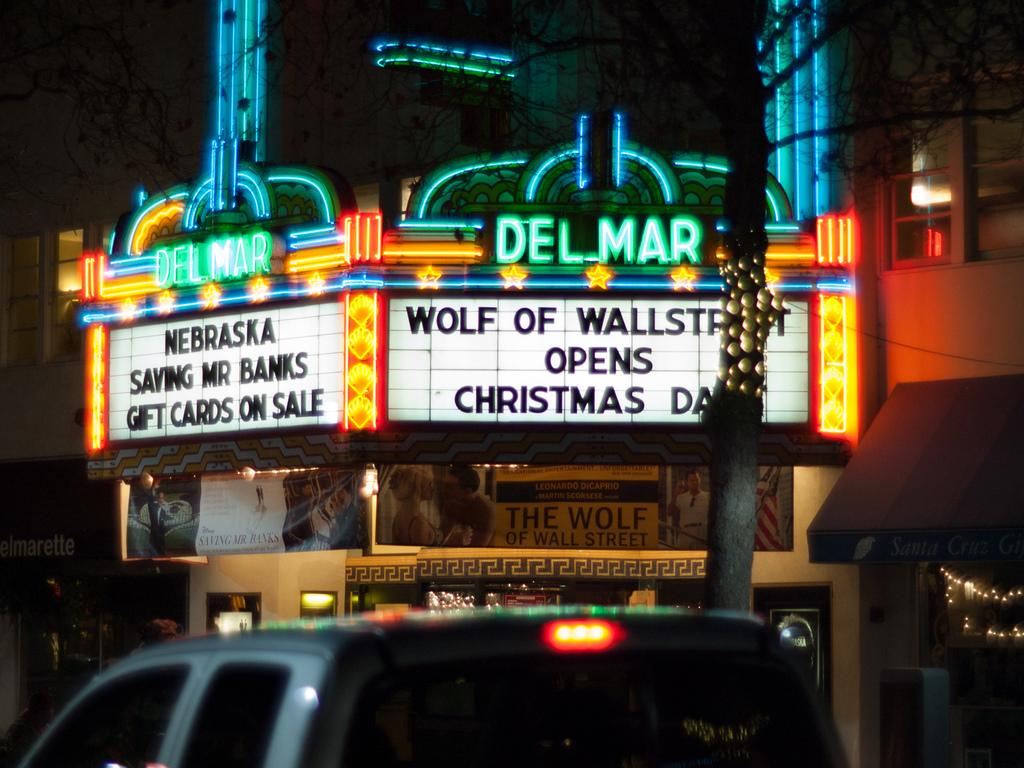What is the main subject of the image? There is a vehicle in the image. What can be seen in the background of the image? There are boards attached to stores in the background of the image. Are there any visible light sources in the image? Yes, there are lights visible in the image. How many kittens are sitting on the plant in the image? There is no plant or kittens present in the image. 